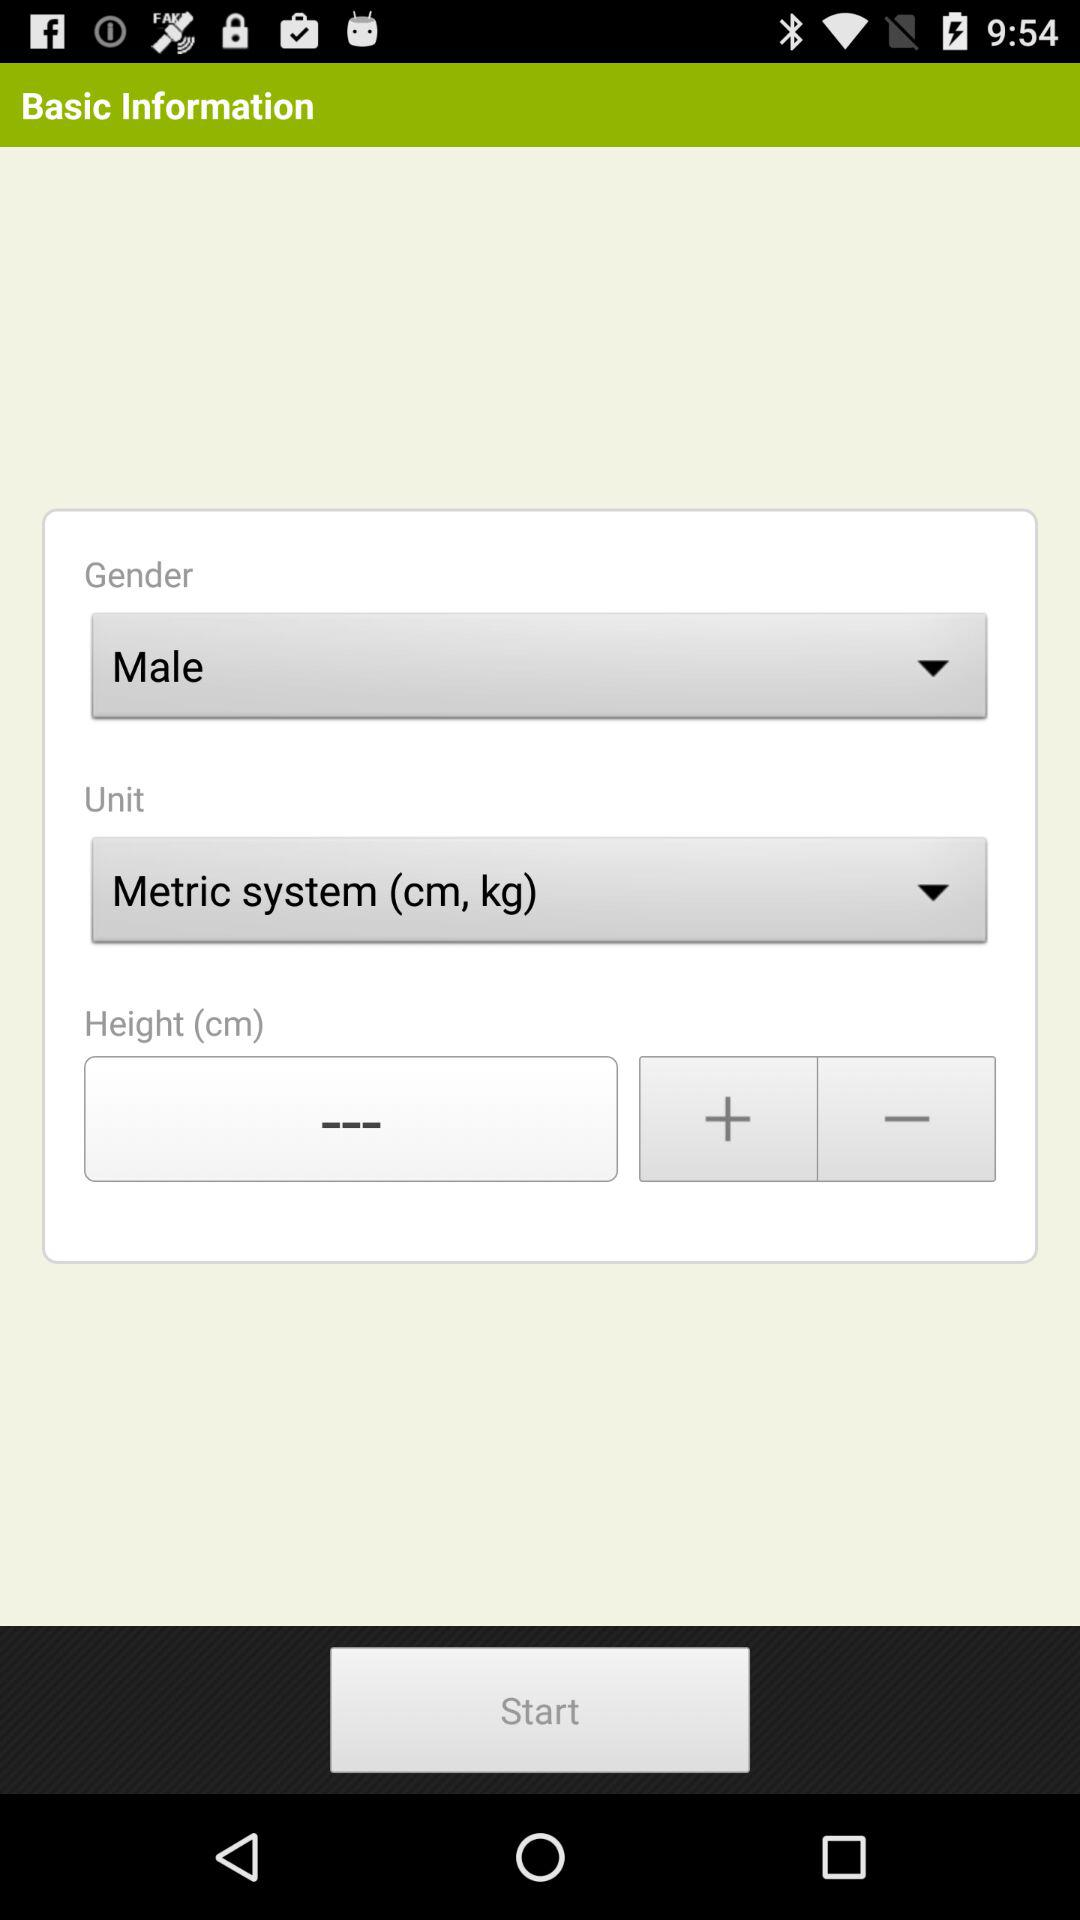What is the selected option in "Unit"? The selected option in "Unit" is "Metric system (cm, kg)". 